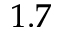<formula> <loc_0><loc_0><loc_500><loc_500>1 . 7</formula> 